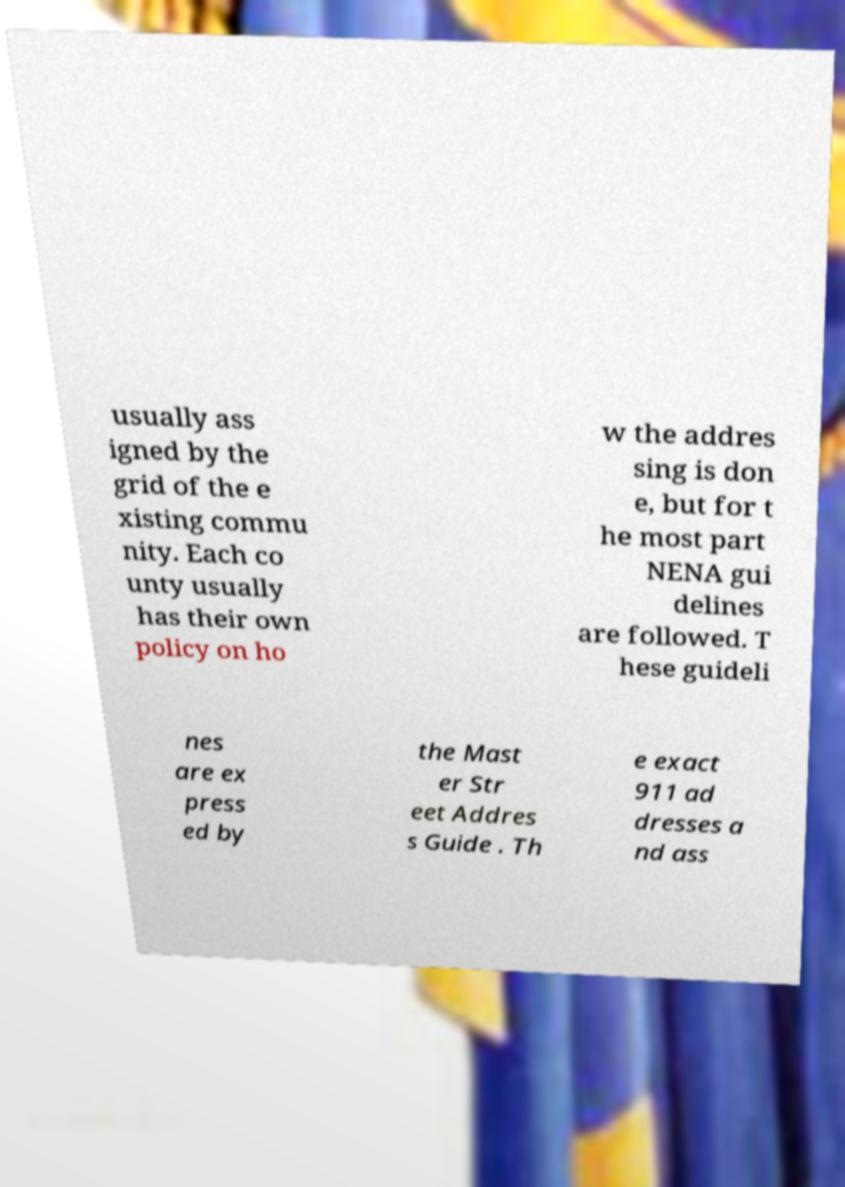Can you accurately transcribe the text from the provided image for me? usually ass igned by the grid of the e xisting commu nity. Each co unty usually has their own policy on ho w the addres sing is don e, but for t he most part NENA gui delines are followed. T hese guideli nes are ex press ed by the Mast er Str eet Addres s Guide . Th e exact 911 ad dresses a nd ass 